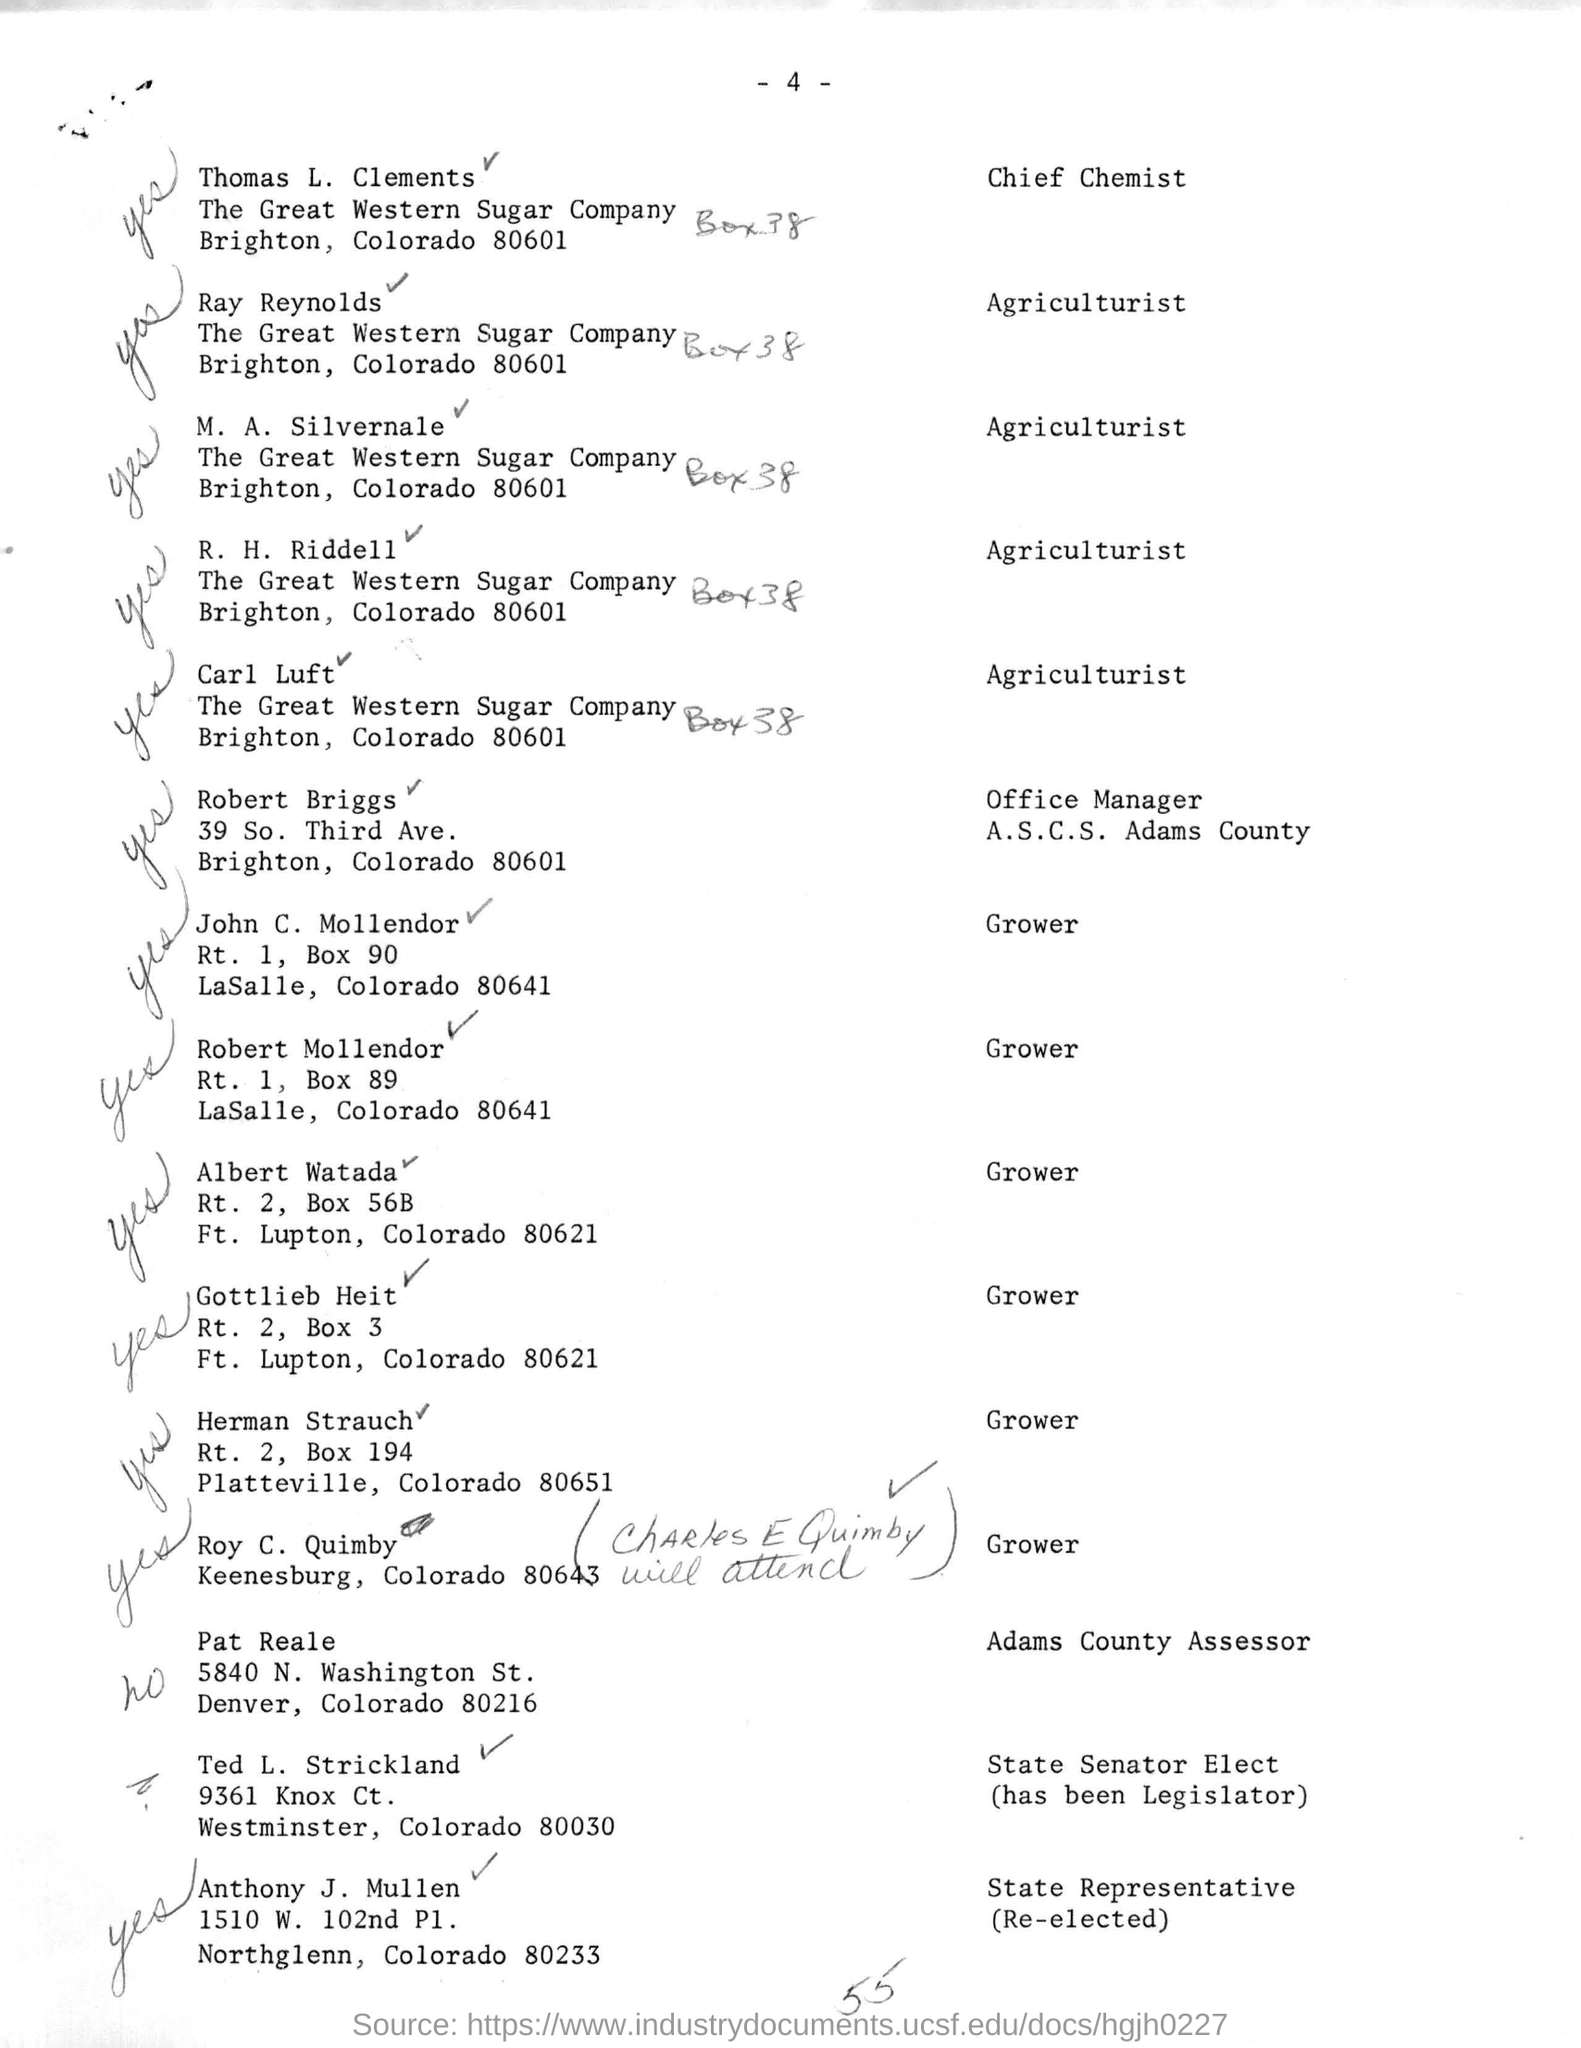What is the name of the chief chemist mentioned ?
Ensure brevity in your answer.  Thomas l. clements. What is the name of the office manager mentioned ?
Your answer should be very brief. Robert briggs. What is the name of the adams county assessor mentioned ?
Ensure brevity in your answer.  Pat reale. What is the name of the state representative mentioned ?
Make the answer very short. Anthony J. Mullen. 